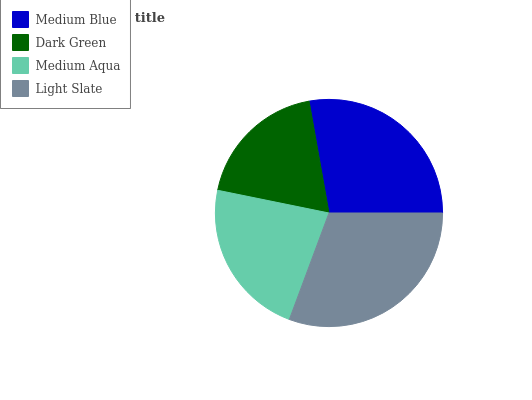Is Dark Green the minimum?
Answer yes or no. Yes. Is Light Slate the maximum?
Answer yes or no. Yes. Is Medium Aqua the minimum?
Answer yes or no. No. Is Medium Aqua the maximum?
Answer yes or no. No. Is Medium Aqua greater than Dark Green?
Answer yes or no. Yes. Is Dark Green less than Medium Aqua?
Answer yes or no. Yes. Is Dark Green greater than Medium Aqua?
Answer yes or no. No. Is Medium Aqua less than Dark Green?
Answer yes or no. No. Is Medium Blue the high median?
Answer yes or no. Yes. Is Medium Aqua the low median?
Answer yes or no. Yes. Is Dark Green the high median?
Answer yes or no. No. Is Light Slate the low median?
Answer yes or no. No. 